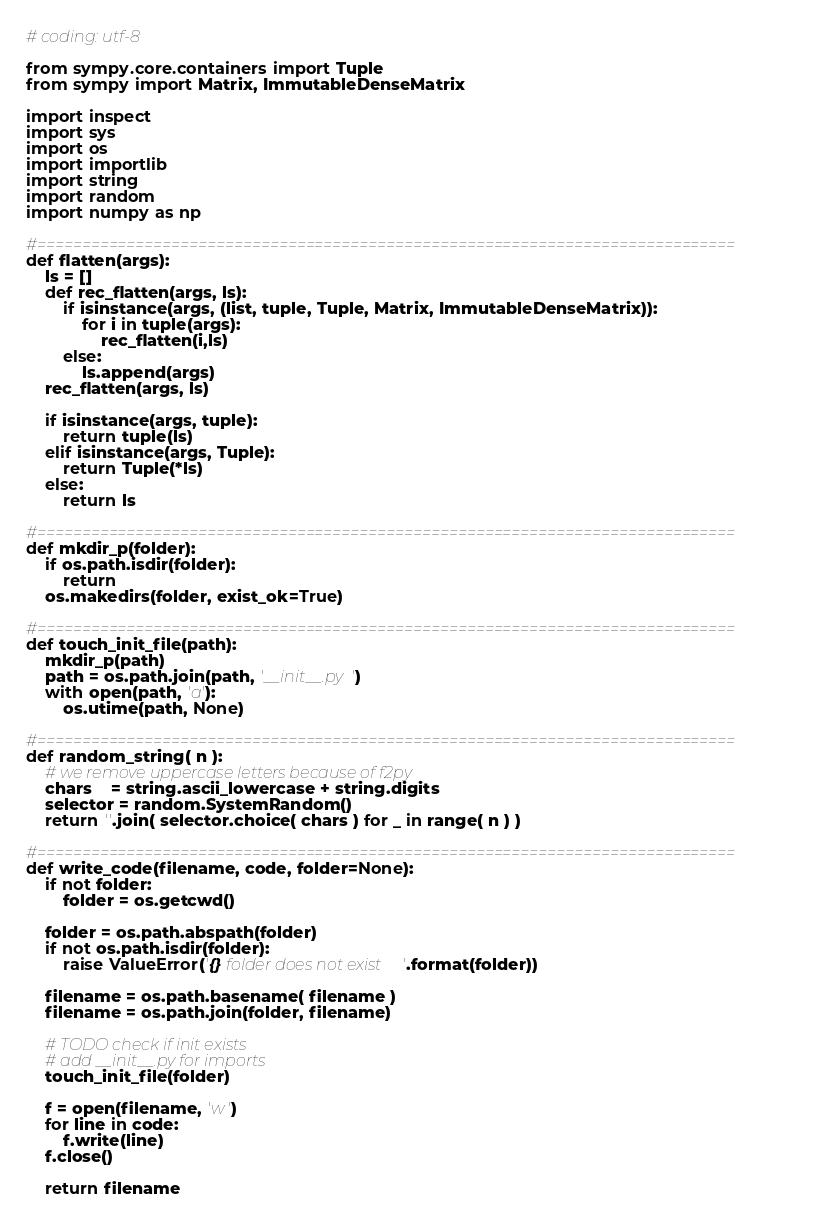Convert code to text. <code><loc_0><loc_0><loc_500><loc_500><_Python_># coding: utf-8

from sympy.core.containers import Tuple
from sympy import Matrix, ImmutableDenseMatrix

import inspect
import sys
import os
import importlib
import string
import random
import numpy as np

#==============================================================================
def flatten(args):
    ls = []
    def rec_flatten(args, ls):
        if isinstance(args, (list, tuple, Tuple, Matrix, ImmutableDenseMatrix)):
            for i in tuple(args):
                rec_flatten(i,ls)
        else:
            ls.append(args)
    rec_flatten(args, ls)

    if isinstance(args, tuple):
        return tuple(ls)
    elif isinstance(args, Tuple):
        return Tuple(*ls)
    else:
        return ls

#==============================================================================
def mkdir_p(folder):
    if os.path.isdir(folder):
        return
    os.makedirs(folder, exist_ok=True)

#==============================================================================
def touch_init_file(path):
    mkdir_p(path)
    path = os.path.join(path, '__init__.py')
    with open(path, 'a'):
        os.utime(path, None)

#==============================================================================
def random_string( n ):
    # we remove uppercase letters because of f2py
    chars    = string.ascii_lowercase + string.digits
    selector = random.SystemRandom()
    return ''.join( selector.choice( chars ) for _ in range( n ) )

#==============================================================================
def write_code(filename, code, folder=None):
    if not folder:
        folder = os.getcwd()

    folder = os.path.abspath(folder)
    if not os.path.isdir(folder):
        raise ValueError('{} folder does not exist'.format(folder))

    filename = os.path.basename( filename )
    filename = os.path.join(folder, filename)

    # TODO check if init exists
    # add __init__.py for imports
    touch_init_file(folder)

    f = open(filename, 'w')
    for line in code:
        f.write(line)
    f.close()

    return filename

</code> 